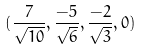<formula> <loc_0><loc_0><loc_500><loc_500>( \frac { 7 } { \sqrt { 1 0 } } , \frac { - 5 } { \sqrt { 6 } } , \frac { - 2 } { \sqrt { 3 } } , 0 )</formula> 